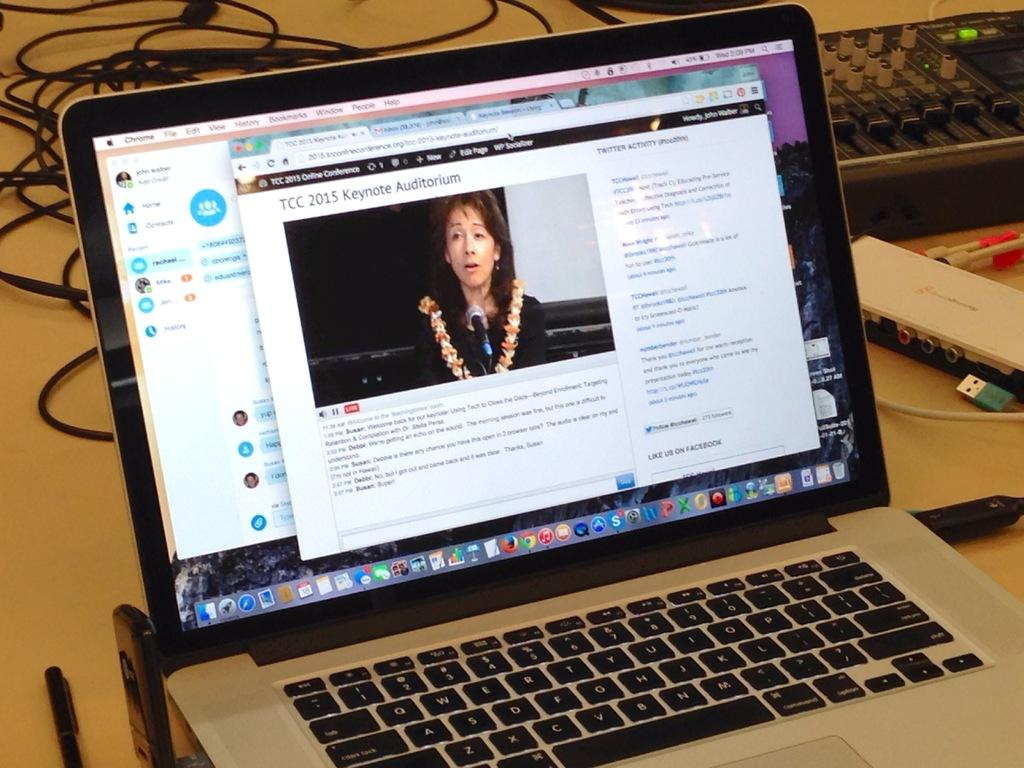Provide a one-sentence caption for the provided image. A laptop with an article brought  up on the screen about TCC 2015 Keynote. 